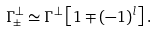Convert formula to latex. <formula><loc_0><loc_0><loc_500><loc_500>\Gamma _ { \pm } ^ { \perp } \simeq \Gamma ^ { \perp } \left [ 1 \mp ( - 1 ) ^ { l } \right ] .</formula> 